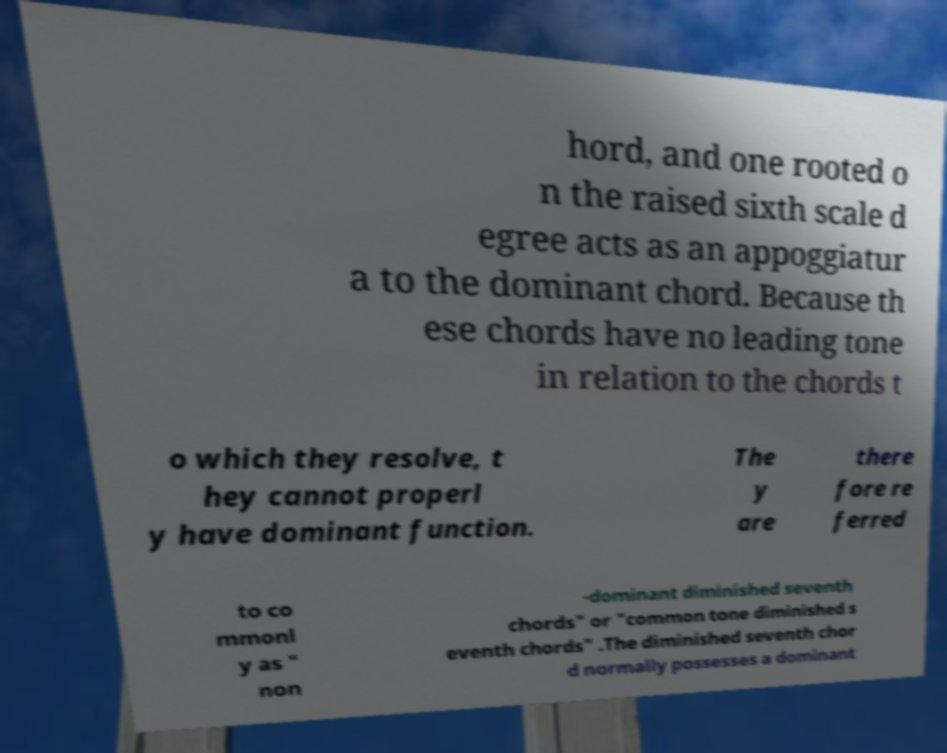Can you read and provide the text displayed in the image?This photo seems to have some interesting text. Can you extract and type it out for me? hord, and one rooted o n the raised sixth scale d egree acts as an appoggiatur a to the dominant chord. Because th ese chords have no leading tone in relation to the chords t o which they resolve, t hey cannot properl y have dominant function. The y are there fore re ferred to co mmonl y as " non -dominant diminished seventh chords" or "common tone diminished s eventh chords" .The diminished seventh chor d normally possesses a dominant 